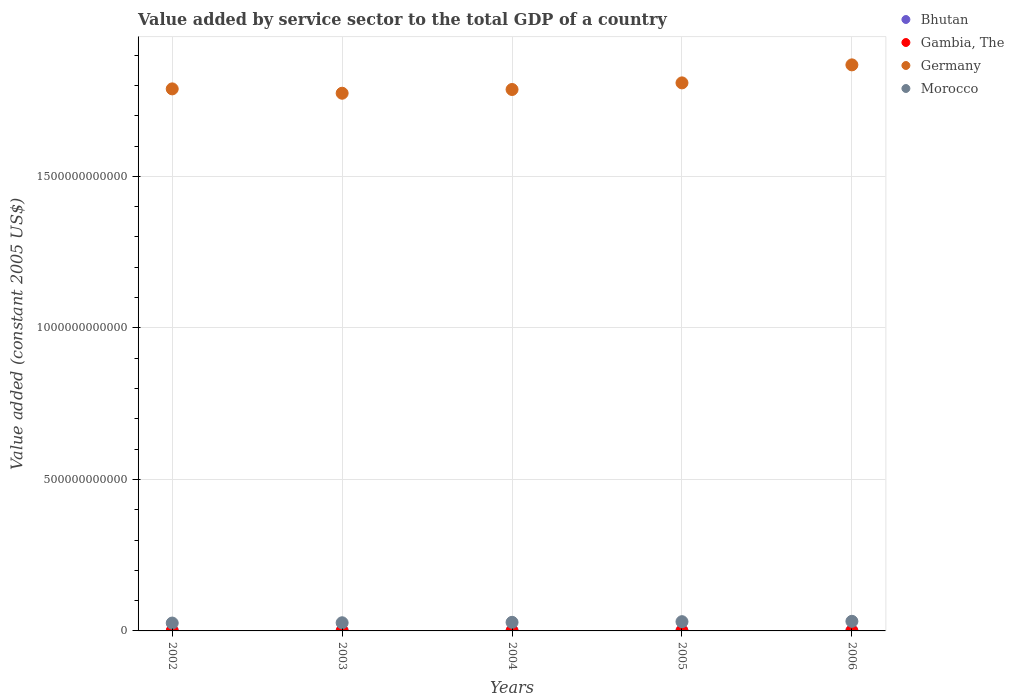What is the value added by service sector in Bhutan in 2002?
Provide a short and direct response. 2.24e+08. Across all years, what is the maximum value added by service sector in Bhutan?
Ensure brevity in your answer.  3.37e+08. Across all years, what is the minimum value added by service sector in Germany?
Provide a succinct answer. 1.77e+12. What is the total value added by service sector in Germany in the graph?
Your answer should be very brief. 9.03e+12. What is the difference between the value added by service sector in Bhutan in 2004 and that in 2006?
Your response must be concise. -6.56e+07. What is the difference between the value added by service sector in Bhutan in 2006 and the value added by service sector in Germany in 2004?
Ensure brevity in your answer.  -1.79e+12. What is the average value added by service sector in Bhutan per year?
Offer a terse response. 2.78e+08. In the year 2004, what is the difference between the value added by service sector in Bhutan and value added by service sector in Morocco?
Your response must be concise. -2.81e+1. In how many years, is the value added by service sector in Germany greater than 1400000000000 US$?
Provide a succinct answer. 5. What is the ratio of the value added by service sector in Bhutan in 2002 to that in 2005?
Ensure brevity in your answer.  0.72. Is the value added by service sector in Germany in 2002 less than that in 2006?
Provide a short and direct response. Yes. Is the difference between the value added by service sector in Bhutan in 2003 and 2005 greater than the difference between the value added by service sector in Morocco in 2003 and 2005?
Your answer should be very brief. Yes. What is the difference between the highest and the second highest value added by service sector in Morocco?
Provide a succinct answer. 1.18e+09. What is the difference between the highest and the lowest value added by service sector in Bhutan?
Your answer should be compact. 1.13e+08. In how many years, is the value added by service sector in Morocco greater than the average value added by service sector in Morocco taken over all years?
Provide a succinct answer. 2. Is it the case that in every year, the sum of the value added by service sector in Morocco and value added by service sector in Germany  is greater than the sum of value added by service sector in Bhutan and value added by service sector in Gambia, The?
Your answer should be very brief. Yes. Is it the case that in every year, the sum of the value added by service sector in Germany and value added by service sector in Bhutan  is greater than the value added by service sector in Gambia, The?
Provide a short and direct response. Yes. Does the value added by service sector in Gambia, The monotonically increase over the years?
Offer a very short reply. No. Is the value added by service sector in Gambia, The strictly greater than the value added by service sector in Bhutan over the years?
Offer a very short reply. Yes. How many dotlines are there?
Your response must be concise. 4. How many years are there in the graph?
Ensure brevity in your answer.  5. What is the difference between two consecutive major ticks on the Y-axis?
Provide a short and direct response. 5.00e+11. Are the values on the major ticks of Y-axis written in scientific E-notation?
Your answer should be compact. No. Does the graph contain grids?
Keep it short and to the point. Yes. How many legend labels are there?
Your response must be concise. 4. What is the title of the graph?
Your answer should be compact. Value added by service sector to the total GDP of a country. Does "High income: nonOECD" appear as one of the legend labels in the graph?
Offer a terse response. No. What is the label or title of the Y-axis?
Make the answer very short. Value added (constant 2005 US$). What is the Value added (constant 2005 US$) of Bhutan in 2002?
Your answer should be compact. 2.24e+08. What is the Value added (constant 2005 US$) of Gambia, The in 2002?
Ensure brevity in your answer.  3.03e+08. What is the Value added (constant 2005 US$) of Germany in 2002?
Keep it short and to the point. 1.79e+12. What is the Value added (constant 2005 US$) in Morocco in 2002?
Ensure brevity in your answer.  2.60e+1. What is the Value added (constant 2005 US$) in Bhutan in 2003?
Keep it short and to the point. 2.45e+08. What is the Value added (constant 2005 US$) in Gambia, The in 2003?
Keep it short and to the point. 3.12e+08. What is the Value added (constant 2005 US$) in Germany in 2003?
Provide a short and direct response. 1.77e+12. What is the Value added (constant 2005 US$) of Morocco in 2003?
Your answer should be compact. 2.69e+1. What is the Value added (constant 2005 US$) in Bhutan in 2004?
Provide a short and direct response. 2.72e+08. What is the Value added (constant 2005 US$) in Gambia, The in 2004?
Offer a terse response. 3.37e+08. What is the Value added (constant 2005 US$) of Germany in 2004?
Ensure brevity in your answer.  1.79e+12. What is the Value added (constant 2005 US$) in Morocco in 2004?
Provide a succinct answer. 2.83e+1. What is the Value added (constant 2005 US$) in Bhutan in 2005?
Provide a succinct answer. 3.12e+08. What is the Value added (constant 2005 US$) of Gambia, The in 2005?
Provide a succinct answer. 3.33e+08. What is the Value added (constant 2005 US$) in Germany in 2005?
Provide a short and direct response. 1.81e+12. What is the Value added (constant 2005 US$) in Morocco in 2005?
Make the answer very short. 3.05e+1. What is the Value added (constant 2005 US$) in Bhutan in 2006?
Your answer should be compact. 3.37e+08. What is the Value added (constant 2005 US$) in Gambia, The in 2006?
Ensure brevity in your answer.  3.59e+08. What is the Value added (constant 2005 US$) in Germany in 2006?
Your response must be concise. 1.87e+12. What is the Value added (constant 2005 US$) of Morocco in 2006?
Provide a succinct answer. 3.17e+1. Across all years, what is the maximum Value added (constant 2005 US$) in Bhutan?
Give a very brief answer. 3.37e+08. Across all years, what is the maximum Value added (constant 2005 US$) of Gambia, The?
Give a very brief answer. 3.59e+08. Across all years, what is the maximum Value added (constant 2005 US$) of Germany?
Ensure brevity in your answer.  1.87e+12. Across all years, what is the maximum Value added (constant 2005 US$) of Morocco?
Ensure brevity in your answer.  3.17e+1. Across all years, what is the minimum Value added (constant 2005 US$) in Bhutan?
Your answer should be compact. 2.24e+08. Across all years, what is the minimum Value added (constant 2005 US$) in Gambia, The?
Provide a short and direct response. 3.03e+08. Across all years, what is the minimum Value added (constant 2005 US$) in Germany?
Your answer should be very brief. 1.77e+12. Across all years, what is the minimum Value added (constant 2005 US$) of Morocco?
Your answer should be very brief. 2.60e+1. What is the total Value added (constant 2005 US$) of Bhutan in the graph?
Give a very brief answer. 1.39e+09. What is the total Value added (constant 2005 US$) in Gambia, The in the graph?
Provide a succinct answer. 1.64e+09. What is the total Value added (constant 2005 US$) of Germany in the graph?
Offer a very short reply. 9.03e+12. What is the total Value added (constant 2005 US$) of Morocco in the graph?
Give a very brief answer. 1.43e+11. What is the difference between the Value added (constant 2005 US$) in Bhutan in 2002 and that in 2003?
Provide a short and direct response. -2.10e+07. What is the difference between the Value added (constant 2005 US$) of Gambia, The in 2002 and that in 2003?
Offer a very short reply. -8.94e+06. What is the difference between the Value added (constant 2005 US$) of Germany in 2002 and that in 2003?
Give a very brief answer. 1.43e+1. What is the difference between the Value added (constant 2005 US$) in Morocco in 2002 and that in 2003?
Make the answer very short. -9.53e+08. What is the difference between the Value added (constant 2005 US$) in Bhutan in 2002 and that in 2004?
Your answer should be compact. -4.75e+07. What is the difference between the Value added (constant 2005 US$) in Gambia, The in 2002 and that in 2004?
Offer a terse response. -3.40e+07. What is the difference between the Value added (constant 2005 US$) in Germany in 2002 and that in 2004?
Offer a very short reply. 2.01e+09. What is the difference between the Value added (constant 2005 US$) in Morocco in 2002 and that in 2004?
Your response must be concise. -2.38e+09. What is the difference between the Value added (constant 2005 US$) in Bhutan in 2002 and that in 2005?
Provide a short and direct response. -8.77e+07. What is the difference between the Value added (constant 2005 US$) of Gambia, The in 2002 and that in 2005?
Offer a terse response. -3.04e+07. What is the difference between the Value added (constant 2005 US$) of Germany in 2002 and that in 2005?
Ensure brevity in your answer.  -1.98e+1. What is the difference between the Value added (constant 2005 US$) in Morocco in 2002 and that in 2005?
Offer a very short reply. -4.56e+09. What is the difference between the Value added (constant 2005 US$) in Bhutan in 2002 and that in 2006?
Your answer should be very brief. -1.13e+08. What is the difference between the Value added (constant 2005 US$) of Gambia, The in 2002 and that in 2006?
Keep it short and to the point. -5.55e+07. What is the difference between the Value added (constant 2005 US$) of Germany in 2002 and that in 2006?
Keep it short and to the point. -7.92e+1. What is the difference between the Value added (constant 2005 US$) of Morocco in 2002 and that in 2006?
Give a very brief answer. -5.74e+09. What is the difference between the Value added (constant 2005 US$) in Bhutan in 2003 and that in 2004?
Make the answer very short. -2.65e+07. What is the difference between the Value added (constant 2005 US$) in Gambia, The in 2003 and that in 2004?
Your answer should be compact. -2.50e+07. What is the difference between the Value added (constant 2005 US$) of Germany in 2003 and that in 2004?
Offer a very short reply. -1.23e+1. What is the difference between the Value added (constant 2005 US$) in Morocco in 2003 and that in 2004?
Make the answer very short. -1.43e+09. What is the difference between the Value added (constant 2005 US$) of Bhutan in 2003 and that in 2005?
Your answer should be compact. -6.67e+07. What is the difference between the Value added (constant 2005 US$) of Gambia, The in 2003 and that in 2005?
Provide a short and direct response. -2.14e+07. What is the difference between the Value added (constant 2005 US$) of Germany in 2003 and that in 2005?
Provide a short and direct response. -3.42e+1. What is the difference between the Value added (constant 2005 US$) of Morocco in 2003 and that in 2005?
Ensure brevity in your answer.  -3.61e+09. What is the difference between the Value added (constant 2005 US$) in Bhutan in 2003 and that in 2006?
Your answer should be very brief. -9.21e+07. What is the difference between the Value added (constant 2005 US$) of Gambia, The in 2003 and that in 2006?
Provide a succinct answer. -4.66e+07. What is the difference between the Value added (constant 2005 US$) in Germany in 2003 and that in 2006?
Ensure brevity in your answer.  -9.36e+1. What is the difference between the Value added (constant 2005 US$) of Morocco in 2003 and that in 2006?
Your response must be concise. -4.79e+09. What is the difference between the Value added (constant 2005 US$) in Bhutan in 2004 and that in 2005?
Make the answer very short. -4.02e+07. What is the difference between the Value added (constant 2005 US$) of Gambia, The in 2004 and that in 2005?
Make the answer very short. 3.62e+06. What is the difference between the Value added (constant 2005 US$) of Germany in 2004 and that in 2005?
Your answer should be compact. -2.18e+1. What is the difference between the Value added (constant 2005 US$) of Morocco in 2004 and that in 2005?
Offer a very short reply. -2.18e+09. What is the difference between the Value added (constant 2005 US$) in Bhutan in 2004 and that in 2006?
Make the answer very short. -6.56e+07. What is the difference between the Value added (constant 2005 US$) of Gambia, The in 2004 and that in 2006?
Your response must be concise. -2.15e+07. What is the difference between the Value added (constant 2005 US$) of Germany in 2004 and that in 2006?
Give a very brief answer. -8.13e+1. What is the difference between the Value added (constant 2005 US$) of Morocco in 2004 and that in 2006?
Provide a succinct answer. -3.36e+09. What is the difference between the Value added (constant 2005 US$) of Bhutan in 2005 and that in 2006?
Offer a terse response. -2.54e+07. What is the difference between the Value added (constant 2005 US$) in Gambia, The in 2005 and that in 2006?
Your answer should be very brief. -2.52e+07. What is the difference between the Value added (constant 2005 US$) of Germany in 2005 and that in 2006?
Ensure brevity in your answer.  -5.94e+1. What is the difference between the Value added (constant 2005 US$) of Morocco in 2005 and that in 2006?
Your response must be concise. -1.18e+09. What is the difference between the Value added (constant 2005 US$) of Bhutan in 2002 and the Value added (constant 2005 US$) of Gambia, The in 2003?
Ensure brevity in your answer.  -8.79e+07. What is the difference between the Value added (constant 2005 US$) of Bhutan in 2002 and the Value added (constant 2005 US$) of Germany in 2003?
Your response must be concise. -1.77e+12. What is the difference between the Value added (constant 2005 US$) in Bhutan in 2002 and the Value added (constant 2005 US$) in Morocco in 2003?
Provide a short and direct response. -2.67e+1. What is the difference between the Value added (constant 2005 US$) of Gambia, The in 2002 and the Value added (constant 2005 US$) of Germany in 2003?
Provide a short and direct response. -1.77e+12. What is the difference between the Value added (constant 2005 US$) of Gambia, The in 2002 and the Value added (constant 2005 US$) of Morocco in 2003?
Give a very brief answer. -2.66e+1. What is the difference between the Value added (constant 2005 US$) in Germany in 2002 and the Value added (constant 2005 US$) in Morocco in 2003?
Your answer should be very brief. 1.76e+12. What is the difference between the Value added (constant 2005 US$) in Bhutan in 2002 and the Value added (constant 2005 US$) in Gambia, The in 2004?
Provide a succinct answer. -1.13e+08. What is the difference between the Value added (constant 2005 US$) of Bhutan in 2002 and the Value added (constant 2005 US$) of Germany in 2004?
Provide a succinct answer. -1.79e+12. What is the difference between the Value added (constant 2005 US$) of Bhutan in 2002 and the Value added (constant 2005 US$) of Morocco in 2004?
Give a very brief answer. -2.81e+1. What is the difference between the Value added (constant 2005 US$) of Gambia, The in 2002 and the Value added (constant 2005 US$) of Germany in 2004?
Your answer should be compact. -1.79e+12. What is the difference between the Value added (constant 2005 US$) in Gambia, The in 2002 and the Value added (constant 2005 US$) in Morocco in 2004?
Your response must be concise. -2.80e+1. What is the difference between the Value added (constant 2005 US$) in Germany in 2002 and the Value added (constant 2005 US$) in Morocco in 2004?
Your response must be concise. 1.76e+12. What is the difference between the Value added (constant 2005 US$) in Bhutan in 2002 and the Value added (constant 2005 US$) in Gambia, The in 2005?
Give a very brief answer. -1.09e+08. What is the difference between the Value added (constant 2005 US$) of Bhutan in 2002 and the Value added (constant 2005 US$) of Germany in 2005?
Ensure brevity in your answer.  -1.81e+12. What is the difference between the Value added (constant 2005 US$) in Bhutan in 2002 and the Value added (constant 2005 US$) in Morocco in 2005?
Your response must be concise. -3.03e+1. What is the difference between the Value added (constant 2005 US$) in Gambia, The in 2002 and the Value added (constant 2005 US$) in Germany in 2005?
Make the answer very short. -1.81e+12. What is the difference between the Value added (constant 2005 US$) of Gambia, The in 2002 and the Value added (constant 2005 US$) of Morocco in 2005?
Make the answer very short. -3.02e+1. What is the difference between the Value added (constant 2005 US$) in Germany in 2002 and the Value added (constant 2005 US$) in Morocco in 2005?
Ensure brevity in your answer.  1.76e+12. What is the difference between the Value added (constant 2005 US$) in Bhutan in 2002 and the Value added (constant 2005 US$) in Gambia, The in 2006?
Give a very brief answer. -1.34e+08. What is the difference between the Value added (constant 2005 US$) in Bhutan in 2002 and the Value added (constant 2005 US$) in Germany in 2006?
Ensure brevity in your answer.  -1.87e+12. What is the difference between the Value added (constant 2005 US$) of Bhutan in 2002 and the Value added (constant 2005 US$) of Morocco in 2006?
Your answer should be very brief. -3.15e+1. What is the difference between the Value added (constant 2005 US$) of Gambia, The in 2002 and the Value added (constant 2005 US$) of Germany in 2006?
Keep it short and to the point. -1.87e+12. What is the difference between the Value added (constant 2005 US$) of Gambia, The in 2002 and the Value added (constant 2005 US$) of Morocco in 2006?
Keep it short and to the point. -3.14e+1. What is the difference between the Value added (constant 2005 US$) of Germany in 2002 and the Value added (constant 2005 US$) of Morocco in 2006?
Your answer should be compact. 1.76e+12. What is the difference between the Value added (constant 2005 US$) of Bhutan in 2003 and the Value added (constant 2005 US$) of Gambia, The in 2004?
Offer a very short reply. -9.19e+07. What is the difference between the Value added (constant 2005 US$) in Bhutan in 2003 and the Value added (constant 2005 US$) in Germany in 2004?
Make the answer very short. -1.79e+12. What is the difference between the Value added (constant 2005 US$) of Bhutan in 2003 and the Value added (constant 2005 US$) of Morocco in 2004?
Keep it short and to the point. -2.81e+1. What is the difference between the Value added (constant 2005 US$) in Gambia, The in 2003 and the Value added (constant 2005 US$) in Germany in 2004?
Your response must be concise. -1.79e+12. What is the difference between the Value added (constant 2005 US$) in Gambia, The in 2003 and the Value added (constant 2005 US$) in Morocco in 2004?
Provide a succinct answer. -2.80e+1. What is the difference between the Value added (constant 2005 US$) in Germany in 2003 and the Value added (constant 2005 US$) in Morocco in 2004?
Give a very brief answer. 1.75e+12. What is the difference between the Value added (constant 2005 US$) of Bhutan in 2003 and the Value added (constant 2005 US$) of Gambia, The in 2005?
Your response must be concise. -8.83e+07. What is the difference between the Value added (constant 2005 US$) in Bhutan in 2003 and the Value added (constant 2005 US$) in Germany in 2005?
Ensure brevity in your answer.  -1.81e+12. What is the difference between the Value added (constant 2005 US$) in Bhutan in 2003 and the Value added (constant 2005 US$) in Morocco in 2005?
Your answer should be compact. -3.03e+1. What is the difference between the Value added (constant 2005 US$) in Gambia, The in 2003 and the Value added (constant 2005 US$) in Germany in 2005?
Give a very brief answer. -1.81e+12. What is the difference between the Value added (constant 2005 US$) of Gambia, The in 2003 and the Value added (constant 2005 US$) of Morocco in 2005?
Provide a short and direct response. -3.02e+1. What is the difference between the Value added (constant 2005 US$) in Germany in 2003 and the Value added (constant 2005 US$) in Morocco in 2005?
Ensure brevity in your answer.  1.74e+12. What is the difference between the Value added (constant 2005 US$) of Bhutan in 2003 and the Value added (constant 2005 US$) of Gambia, The in 2006?
Your response must be concise. -1.13e+08. What is the difference between the Value added (constant 2005 US$) in Bhutan in 2003 and the Value added (constant 2005 US$) in Germany in 2006?
Your answer should be compact. -1.87e+12. What is the difference between the Value added (constant 2005 US$) in Bhutan in 2003 and the Value added (constant 2005 US$) in Morocco in 2006?
Your answer should be very brief. -3.15e+1. What is the difference between the Value added (constant 2005 US$) of Gambia, The in 2003 and the Value added (constant 2005 US$) of Germany in 2006?
Provide a succinct answer. -1.87e+12. What is the difference between the Value added (constant 2005 US$) in Gambia, The in 2003 and the Value added (constant 2005 US$) in Morocco in 2006?
Offer a very short reply. -3.14e+1. What is the difference between the Value added (constant 2005 US$) in Germany in 2003 and the Value added (constant 2005 US$) in Morocco in 2006?
Provide a short and direct response. 1.74e+12. What is the difference between the Value added (constant 2005 US$) of Bhutan in 2004 and the Value added (constant 2005 US$) of Gambia, The in 2005?
Your answer should be very brief. -6.18e+07. What is the difference between the Value added (constant 2005 US$) of Bhutan in 2004 and the Value added (constant 2005 US$) of Germany in 2005?
Offer a terse response. -1.81e+12. What is the difference between the Value added (constant 2005 US$) in Bhutan in 2004 and the Value added (constant 2005 US$) in Morocco in 2005?
Provide a short and direct response. -3.03e+1. What is the difference between the Value added (constant 2005 US$) in Gambia, The in 2004 and the Value added (constant 2005 US$) in Germany in 2005?
Provide a succinct answer. -1.81e+12. What is the difference between the Value added (constant 2005 US$) in Gambia, The in 2004 and the Value added (constant 2005 US$) in Morocco in 2005?
Your answer should be very brief. -3.02e+1. What is the difference between the Value added (constant 2005 US$) in Germany in 2004 and the Value added (constant 2005 US$) in Morocco in 2005?
Give a very brief answer. 1.76e+12. What is the difference between the Value added (constant 2005 US$) of Bhutan in 2004 and the Value added (constant 2005 US$) of Gambia, The in 2006?
Make the answer very short. -8.70e+07. What is the difference between the Value added (constant 2005 US$) of Bhutan in 2004 and the Value added (constant 2005 US$) of Germany in 2006?
Keep it short and to the point. -1.87e+12. What is the difference between the Value added (constant 2005 US$) of Bhutan in 2004 and the Value added (constant 2005 US$) of Morocco in 2006?
Ensure brevity in your answer.  -3.14e+1. What is the difference between the Value added (constant 2005 US$) of Gambia, The in 2004 and the Value added (constant 2005 US$) of Germany in 2006?
Give a very brief answer. -1.87e+12. What is the difference between the Value added (constant 2005 US$) of Gambia, The in 2004 and the Value added (constant 2005 US$) of Morocco in 2006?
Provide a succinct answer. -3.14e+1. What is the difference between the Value added (constant 2005 US$) of Germany in 2004 and the Value added (constant 2005 US$) of Morocco in 2006?
Give a very brief answer. 1.75e+12. What is the difference between the Value added (constant 2005 US$) of Bhutan in 2005 and the Value added (constant 2005 US$) of Gambia, The in 2006?
Ensure brevity in your answer.  -4.68e+07. What is the difference between the Value added (constant 2005 US$) in Bhutan in 2005 and the Value added (constant 2005 US$) in Germany in 2006?
Make the answer very short. -1.87e+12. What is the difference between the Value added (constant 2005 US$) of Bhutan in 2005 and the Value added (constant 2005 US$) of Morocco in 2006?
Provide a succinct answer. -3.14e+1. What is the difference between the Value added (constant 2005 US$) of Gambia, The in 2005 and the Value added (constant 2005 US$) of Germany in 2006?
Keep it short and to the point. -1.87e+12. What is the difference between the Value added (constant 2005 US$) of Gambia, The in 2005 and the Value added (constant 2005 US$) of Morocco in 2006?
Make the answer very short. -3.14e+1. What is the difference between the Value added (constant 2005 US$) of Germany in 2005 and the Value added (constant 2005 US$) of Morocco in 2006?
Your answer should be very brief. 1.78e+12. What is the average Value added (constant 2005 US$) of Bhutan per year?
Provide a succinct answer. 2.78e+08. What is the average Value added (constant 2005 US$) in Gambia, The per year?
Make the answer very short. 3.29e+08. What is the average Value added (constant 2005 US$) of Germany per year?
Ensure brevity in your answer.  1.81e+12. What is the average Value added (constant 2005 US$) of Morocco per year?
Your answer should be very brief. 2.87e+1. In the year 2002, what is the difference between the Value added (constant 2005 US$) in Bhutan and Value added (constant 2005 US$) in Gambia, The?
Your response must be concise. -7.90e+07. In the year 2002, what is the difference between the Value added (constant 2005 US$) in Bhutan and Value added (constant 2005 US$) in Germany?
Your response must be concise. -1.79e+12. In the year 2002, what is the difference between the Value added (constant 2005 US$) in Bhutan and Value added (constant 2005 US$) in Morocco?
Offer a terse response. -2.57e+1. In the year 2002, what is the difference between the Value added (constant 2005 US$) in Gambia, The and Value added (constant 2005 US$) in Germany?
Ensure brevity in your answer.  -1.79e+12. In the year 2002, what is the difference between the Value added (constant 2005 US$) of Gambia, The and Value added (constant 2005 US$) of Morocco?
Keep it short and to the point. -2.57e+1. In the year 2002, what is the difference between the Value added (constant 2005 US$) of Germany and Value added (constant 2005 US$) of Morocco?
Provide a short and direct response. 1.76e+12. In the year 2003, what is the difference between the Value added (constant 2005 US$) in Bhutan and Value added (constant 2005 US$) in Gambia, The?
Offer a very short reply. -6.69e+07. In the year 2003, what is the difference between the Value added (constant 2005 US$) in Bhutan and Value added (constant 2005 US$) in Germany?
Provide a succinct answer. -1.77e+12. In the year 2003, what is the difference between the Value added (constant 2005 US$) of Bhutan and Value added (constant 2005 US$) of Morocco?
Your answer should be very brief. -2.67e+1. In the year 2003, what is the difference between the Value added (constant 2005 US$) of Gambia, The and Value added (constant 2005 US$) of Germany?
Offer a very short reply. -1.77e+12. In the year 2003, what is the difference between the Value added (constant 2005 US$) of Gambia, The and Value added (constant 2005 US$) of Morocco?
Offer a terse response. -2.66e+1. In the year 2003, what is the difference between the Value added (constant 2005 US$) in Germany and Value added (constant 2005 US$) in Morocco?
Keep it short and to the point. 1.75e+12. In the year 2004, what is the difference between the Value added (constant 2005 US$) of Bhutan and Value added (constant 2005 US$) of Gambia, The?
Offer a very short reply. -6.55e+07. In the year 2004, what is the difference between the Value added (constant 2005 US$) in Bhutan and Value added (constant 2005 US$) in Germany?
Ensure brevity in your answer.  -1.79e+12. In the year 2004, what is the difference between the Value added (constant 2005 US$) in Bhutan and Value added (constant 2005 US$) in Morocco?
Provide a short and direct response. -2.81e+1. In the year 2004, what is the difference between the Value added (constant 2005 US$) in Gambia, The and Value added (constant 2005 US$) in Germany?
Offer a very short reply. -1.79e+12. In the year 2004, what is the difference between the Value added (constant 2005 US$) of Gambia, The and Value added (constant 2005 US$) of Morocco?
Provide a short and direct response. -2.80e+1. In the year 2004, what is the difference between the Value added (constant 2005 US$) of Germany and Value added (constant 2005 US$) of Morocco?
Offer a terse response. 1.76e+12. In the year 2005, what is the difference between the Value added (constant 2005 US$) in Bhutan and Value added (constant 2005 US$) in Gambia, The?
Your answer should be compact. -2.16e+07. In the year 2005, what is the difference between the Value added (constant 2005 US$) of Bhutan and Value added (constant 2005 US$) of Germany?
Your answer should be compact. -1.81e+12. In the year 2005, what is the difference between the Value added (constant 2005 US$) of Bhutan and Value added (constant 2005 US$) of Morocco?
Your answer should be compact. -3.02e+1. In the year 2005, what is the difference between the Value added (constant 2005 US$) of Gambia, The and Value added (constant 2005 US$) of Germany?
Provide a succinct answer. -1.81e+12. In the year 2005, what is the difference between the Value added (constant 2005 US$) in Gambia, The and Value added (constant 2005 US$) in Morocco?
Your response must be concise. -3.02e+1. In the year 2005, what is the difference between the Value added (constant 2005 US$) of Germany and Value added (constant 2005 US$) of Morocco?
Keep it short and to the point. 1.78e+12. In the year 2006, what is the difference between the Value added (constant 2005 US$) in Bhutan and Value added (constant 2005 US$) in Gambia, The?
Give a very brief answer. -2.13e+07. In the year 2006, what is the difference between the Value added (constant 2005 US$) in Bhutan and Value added (constant 2005 US$) in Germany?
Your answer should be compact. -1.87e+12. In the year 2006, what is the difference between the Value added (constant 2005 US$) in Bhutan and Value added (constant 2005 US$) in Morocco?
Offer a very short reply. -3.14e+1. In the year 2006, what is the difference between the Value added (constant 2005 US$) of Gambia, The and Value added (constant 2005 US$) of Germany?
Your answer should be compact. -1.87e+12. In the year 2006, what is the difference between the Value added (constant 2005 US$) in Gambia, The and Value added (constant 2005 US$) in Morocco?
Your response must be concise. -3.13e+1. In the year 2006, what is the difference between the Value added (constant 2005 US$) in Germany and Value added (constant 2005 US$) in Morocco?
Your answer should be very brief. 1.84e+12. What is the ratio of the Value added (constant 2005 US$) of Bhutan in 2002 to that in 2003?
Your answer should be very brief. 0.91. What is the ratio of the Value added (constant 2005 US$) in Gambia, The in 2002 to that in 2003?
Your answer should be compact. 0.97. What is the ratio of the Value added (constant 2005 US$) in Germany in 2002 to that in 2003?
Ensure brevity in your answer.  1.01. What is the ratio of the Value added (constant 2005 US$) in Morocco in 2002 to that in 2003?
Your answer should be very brief. 0.96. What is the ratio of the Value added (constant 2005 US$) in Bhutan in 2002 to that in 2004?
Ensure brevity in your answer.  0.83. What is the ratio of the Value added (constant 2005 US$) of Gambia, The in 2002 to that in 2004?
Your answer should be compact. 0.9. What is the ratio of the Value added (constant 2005 US$) in Morocco in 2002 to that in 2004?
Provide a short and direct response. 0.92. What is the ratio of the Value added (constant 2005 US$) of Bhutan in 2002 to that in 2005?
Offer a very short reply. 0.72. What is the ratio of the Value added (constant 2005 US$) in Gambia, The in 2002 to that in 2005?
Ensure brevity in your answer.  0.91. What is the ratio of the Value added (constant 2005 US$) of Germany in 2002 to that in 2005?
Your response must be concise. 0.99. What is the ratio of the Value added (constant 2005 US$) of Morocco in 2002 to that in 2005?
Provide a succinct answer. 0.85. What is the ratio of the Value added (constant 2005 US$) in Bhutan in 2002 to that in 2006?
Offer a terse response. 0.66. What is the ratio of the Value added (constant 2005 US$) of Gambia, The in 2002 to that in 2006?
Provide a succinct answer. 0.85. What is the ratio of the Value added (constant 2005 US$) in Germany in 2002 to that in 2006?
Offer a terse response. 0.96. What is the ratio of the Value added (constant 2005 US$) of Morocco in 2002 to that in 2006?
Your answer should be very brief. 0.82. What is the ratio of the Value added (constant 2005 US$) in Bhutan in 2003 to that in 2004?
Your answer should be very brief. 0.9. What is the ratio of the Value added (constant 2005 US$) of Gambia, The in 2003 to that in 2004?
Provide a succinct answer. 0.93. What is the ratio of the Value added (constant 2005 US$) of Germany in 2003 to that in 2004?
Your response must be concise. 0.99. What is the ratio of the Value added (constant 2005 US$) of Morocco in 2003 to that in 2004?
Offer a terse response. 0.95. What is the ratio of the Value added (constant 2005 US$) in Bhutan in 2003 to that in 2005?
Your response must be concise. 0.79. What is the ratio of the Value added (constant 2005 US$) in Gambia, The in 2003 to that in 2005?
Keep it short and to the point. 0.94. What is the ratio of the Value added (constant 2005 US$) in Germany in 2003 to that in 2005?
Your response must be concise. 0.98. What is the ratio of the Value added (constant 2005 US$) in Morocco in 2003 to that in 2005?
Your response must be concise. 0.88. What is the ratio of the Value added (constant 2005 US$) of Bhutan in 2003 to that in 2006?
Your response must be concise. 0.73. What is the ratio of the Value added (constant 2005 US$) in Gambia, The in 2003 to that in 2006?
Provide a succinct answer. 0.87. What is the ratio of the Value added (constant 2005 US$) of Germany in 2003 to that in 2006?
Offer a very short reply. 0.95. What is the ratio of the Value added (constant 2005 US$) of Morocco in 2003 to that in 2006?
Make the answer very short. 0.85. What is the ratio of the Value added (constant 2005 US$) in Bhutan in 2004 to that in 2005?
Offer a terse response. 0.87. What is the ratio of the Value added (constant 2005 US$) in Gambia, The in 2004 to that in 2005?
Your response must be concise. 1.01. What is the ratio of the Value added (constant 2005 US$) of Germany in 2004 to that in 2005?
Your answer should be compact. 0.99. What is the ratio of the Value added (constant 2005 US$) in Morocco in 2004 to that in 2005?
Your answer should be very brief. 0.93. What is the ratio of the Value added (constant 2005 US$) in Bhutan in 2004 to that in 2006?
Your answer should be compact. 0.81. What is the ratio of the Value added (constant 2005 US$) in Gambia, The in 2004 to that in 2006?
Offer a terse response. 0.94. What is the ratio of the Value added (constant 2005 US$) of Germany in 2004 to that in 2006?
Make the answer very short. 0.96. What is the ratio of the Value added (constant 2005 US$) in Morocco in 2004 to that in 2006?
Provide a succinct answer. 0.89. What is the ratio of the Value added (constant 2005 US$) in Bhutan in 2005 to that in 2006?
Make the answer very short. 0.92. What is the ratio of the Value added (constant 2005 US$) in Gambia, The in 2005 to that in 2006?
Your answer should be very brief. 0.93. What is the ratio of the Value added (constant 2005 US$) of Germany in 2005 to that in 2006?
Offer a very short reply. 0.97. What is the ratio of the Value added (constant 2005 US$) of Morocco in 2005 to that in 2006?
Your answer should be compact. 0.96. What is the difference between the highest and the second highest Value added (constant 2005 US$) in Bhutan?
Provide a succinct answer. 2.54e+07. What is the difference between the highest and the second highest Value added (constant 2005 US$) of Gambia, The?
Ensure brevity in your answer.  2.15e+07. What is the difference between the highest and the second highest Value added (constant 2005 US$) in Germany?
Give a very brief answer. 5.94e+1. What is the difference between the highest and the second highest Value added (constant 2005 US$) in Morocco?
Offer a very short reply. 1.18e+09. What is the difference between the highest and the lowest Value added (constant 2005 US$) of Bhutan?
Your response must be concise. 1.13e+08. What is the difference between the highest and the lowest Value added (constant 2005 US$) in Gambia, The?
Offer a terse response. 5.55e+07. What is the difference between the highest and the lowest Value added (constant 2005 US$) in Germany?
Provide a short and direct response. 9.36e+1. What is the difference between the highest and the lowest Value added (constant 2005 US$) in Morocco?
Give a very brief answer. 5.74e+09. 